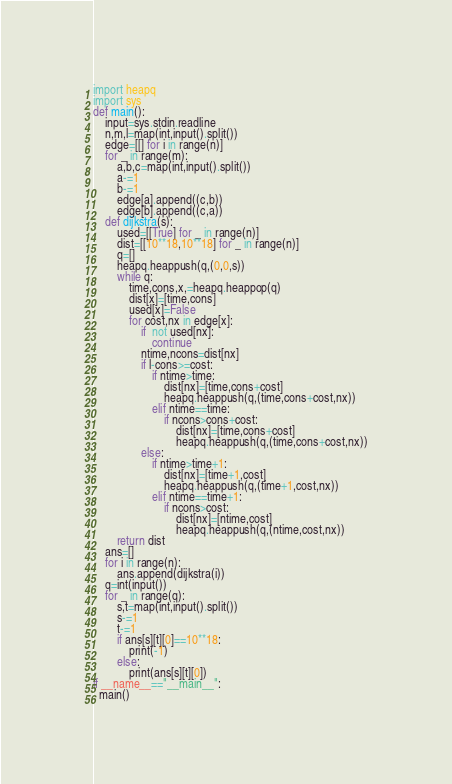<code> <loc_0><loc_0><loc_500><loc_500><_Python_>import heapq
import sys
def main():
    input=sys.stdin.readline
    n,m,l=map(int,input().split())
    edge=[[] for i in range(n)]
    for _ in range(m):
        a,b,c=map(int,input().split())
        a-=1
        b-=1
        edge[a].append((c,b))
        edge[b].append((c,a))
    def dijkstra(s):
        used=[[True] for _ in range(n)]
        dist=[[10**18,10**18] for _ in range(n)]
        q=[]
        heapq.heappush(q,(0,0,s))
        while q:
            time,cons,x,=heapq.heappop(q)
            dist[x]=[time,cons]
            used[x]=False
            for cost,nx in edge[x]:
                if  not used[nx]:
                    continue
                ntime,ncons=dist[nx]
                if l-cons>=cost:
                    if ntime>time:
                        dist[nx]=[time,cons+cost]
                        heapq.heappush(q,(time,cons+cost,nx))
                    elif ntime==time:
                        if ncons>cons+cost:
                            dist[nx]=[time,cons+cost]
                            heapq.heappush(q,(time,cons+cost,nx))
                else:
                    if ntime>time+1:
                        dist[nx]=[time+1,cost]
                        heapq.heappush(q,(time+1,cost,nx))
                    elif ntime==time+1:
                        if ncons>cost:
                            dist[nx]=[ntime,cost]
                            heapq.heappush(q,(ntime,cost,nx))
        return dist
    ans=[]
    for i in range(n):
        ans.append(dijkstra(i))
    q=int(input())
    for _ in range(q):
        s,t=map(int,input().split())
        s-=1
        t-=1
        if ans[s][t][0]==10**18:
            print(-1)
        else:
            print(ans[s][t][0])
if __name__=="__main__":
  main()</code> 